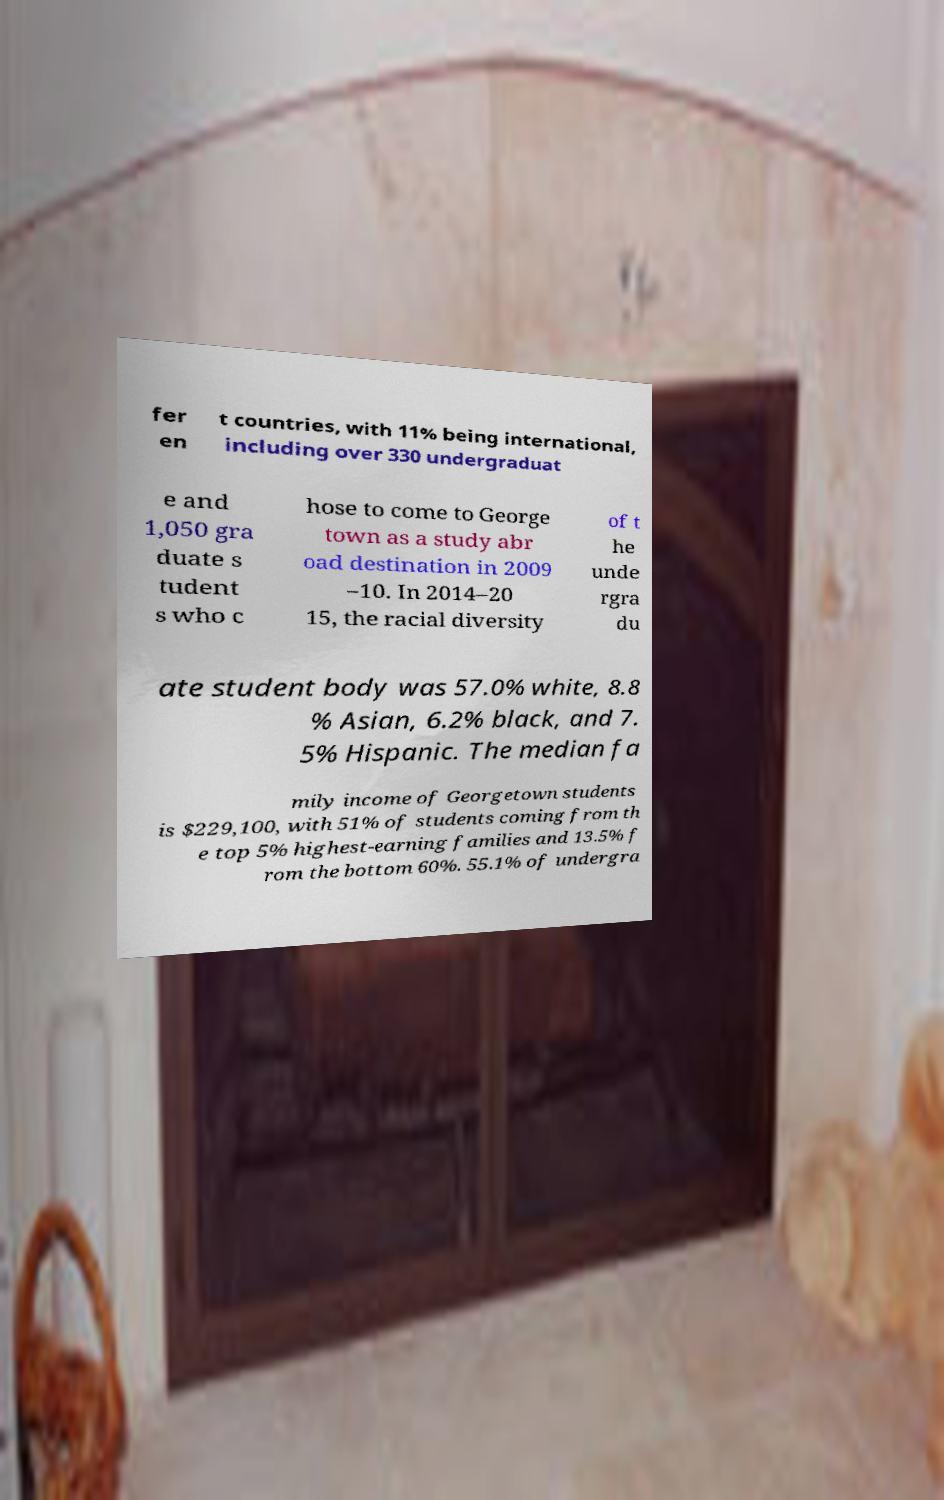What messages or text are displayed in this image? I need them in a readable, typed format. fer en t countries, with 11% being international, including over 330 undergraduat e and 1,050 gra duate s tudent s who c hose to come to George town as a study abr oad destination in 2009 –10. In 2014–20 15, the racial diversity of t he unde rgra du ate student body was 57.0% white, 8.8 % Asian, 6.2% black, and 7. 5% Hispanic. The median fa mily income of Georgetown students is $229,100, with 51% of students coming from th e top 5% highest-earning families and 13.5% f rom the bottom 60%. 55.1% of undergra 